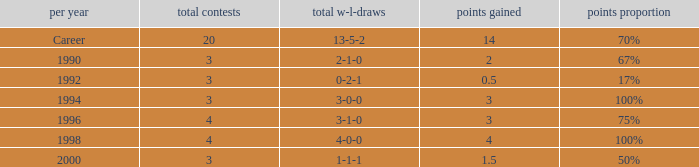Can you tell me the lowest Points won that has the Total matches of 4, and the Total W-L-H of 4-0-0? 4.0. 